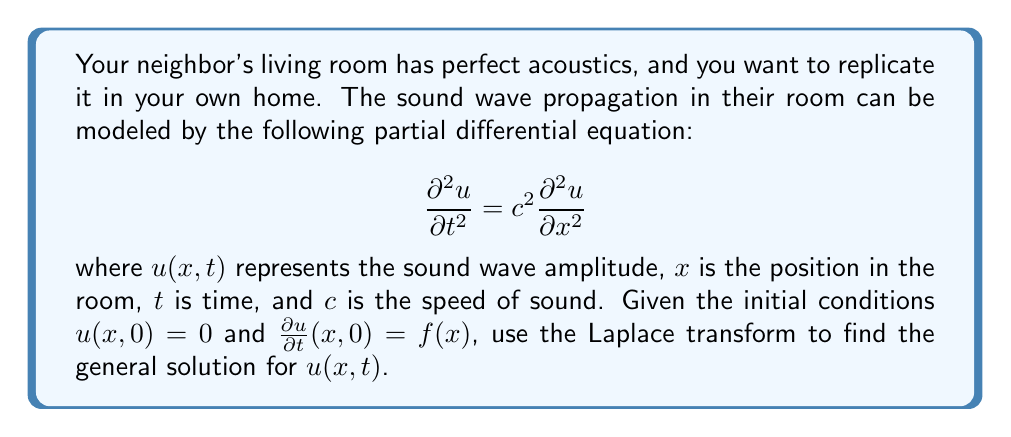Teach me how to tackle this problem. To solve this problem using Laplace transforms, we'll follow these steps:

1) Apply the Laplace transform with respect to $t$ to both sides of the equation:

   $$\mathcal{L}\left\{\frac{\partial^2 u}{\partial t^2}\right\} = c^2 \mathcal{L}\left\{\frac{\partial^2 u}{\partial x^2}\right\}$$

2) Using the Laplace transform properties:

   $$s^2U(x,s) - su(x,0) - \frac{\partial u}{\partial t}(x,0) = c^2\frac{\partial^2 U}{\partial x^2}(x,s)$$

   where $U(x,s)$ is the Laplace transform of $u(x,t)$.

3) Substitute the initial conditions:

   $$s^2U(x,s) - 0 - f(x) = c^2\frac{\partial^2 U}{\partial x^2}(x,s)$$

4) Rearrange the equation:

   $$\frac{\partial^2 U}{\partial x^2}(x,s) - \frac{s^2}{c^2}U(x,s) = -\frac{f(x)}{c^2}$$

5) This is a second-order ordinary differential equation in $x$. Its general solution is:

   $$U(x,s) = A(s)e^{\frac{sx}{c}} + B(s)e^{-\frac{sx}{c}} + \frac{1}{s}\mathcal{F}(s)$$

   where $\mathcal{F}(s)$ is the Laplace transform of $f(x)$, and $A(s)$ and $B(s)$ are functions of $s$ determined by boundary conditions.

6) To find $u(x,t)$, we need to apply the inverse Laplace transform:

   $$u(x,t) = \mathcal{L}^{-1}\{U(x,s)\}$$

7) Using the convolution theorem and the inverse Laplace transform properties:

   $$u(x,t) = \frac{1}{2}\left[f(x+ct) + f(x-ct)\right]$$

This is the D'Alembert's solution to the wave equation.
Answer: The general solution for $u(x,t)$ is:

$$u(x,t) = \frac{1}{2}\left[f(x+ct) + f(x-ct)\right]$$

where $f(x)$ is the initial velocity distribution. 